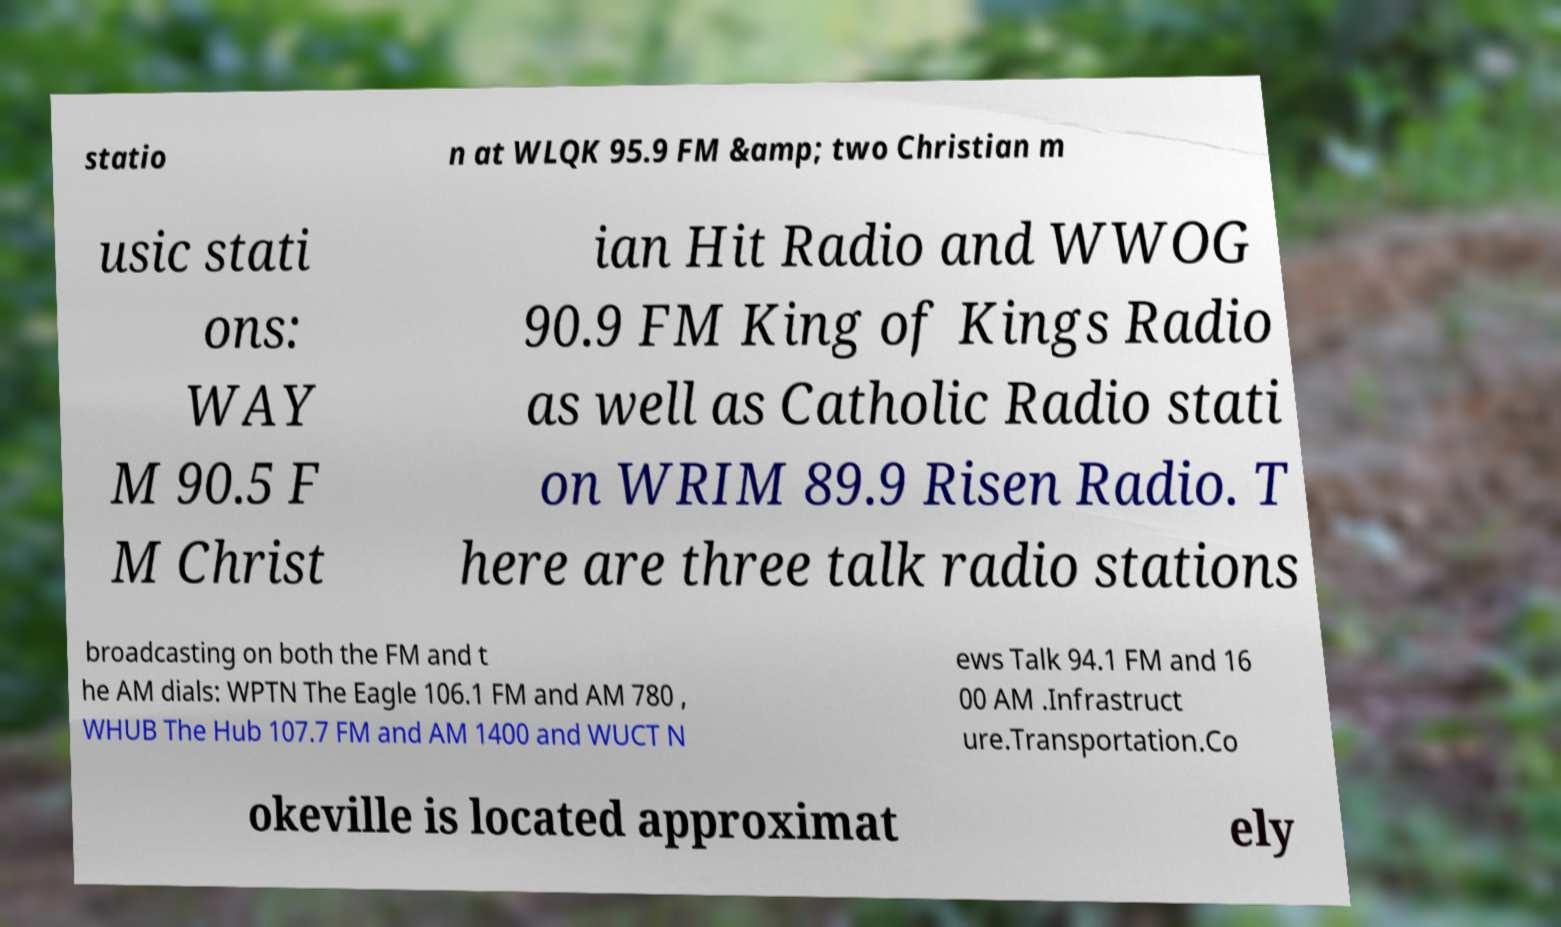Can you read and provide the text displayed in the image?This photo seems to have some interesting text. Can you extract and type it out for me? statio n at WLQK 95.9 FM &amp; two Christian m usic stati ons: WAY M 90.5 F M Christ ian Hit Radio and WWOG 90.9 FM King of Kings Radio as well as Catholic Radio stati on WRIM 89.9 Risen Radio. T here are three talk radio stations broadcasting on both the FM and t he AM dials: WPTN The Eagle 106.1 FM and AM 780 , WHUB The Hub 107.7 FM and AM 1400 and WUCT N ews Talk 94.1 FM and 16 00 AM .Infrastruct ure.Transportation.Co okeville is located approximat ely 